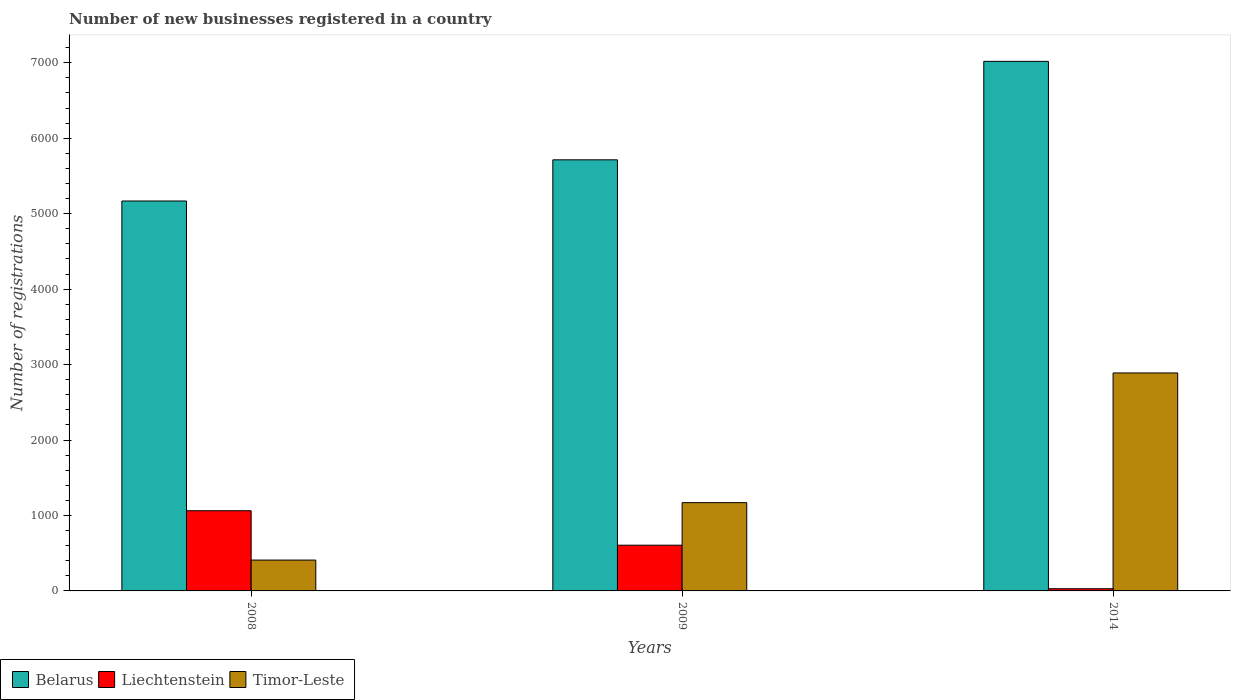How many different coloured bars are there?
Your response must be concise. 3. How many groups of bars are there?
Keep it short and to the point. 3. Are the number of bars per tick equal to the number of legend labels?
Make the answer very short. Yes. In how many cases, is the number of bars for a given year not equal to the number of legend labels?
Provide a short and direct response. 0. What is the number of new businesses registered in Belarus in 2009?
Make the answer very short. 5714. Across all years, what is the maximum number of new businesses registered in Belarus?
Ensure brevity in your answer.  7019. In which year was the number of new businesses registered in Timor-Leste maximum?
Provide a succinct answer. 2014. In which year was the number of new businesses registered in Timor-Leste minimum?
Provide a short and direct response. 2008. What is the total number of new businesses registered in Belarus in the graph?
Make the answer very short. 1.79e+04. What is the difference between the number of new businesses registered in Liechtenstein in 2009 and that in 2014?
Ensure brevity in your answer.  577. What is the difference between the number of new businesses registered in Liechtenstein in 2008 and the number of new businesses registered in Timor-Leste in 2009?
Your response must be concise. -107. What is the average number of new businesses registered in Belarus per year?
Your answer should be compact. 5967. In the year 2014, what is the difference between the number of new businesses registered in Timor-Leste and number of new businesses registered in Belarus?
Keep it short and to the point. -4130. What is the ratio of the number of new businesses registered in Liechtenstein in 2008 to that in 2009?
Your answer should be compact. 1.75. Is the number of new businesses registered in Belarus in 2008 less than that in 2009?
Provide a succinct answer. Yes. Is the difference between the number of new businesses registered in Timor-Leste in 2008 and 2014 greater than the difference between the number of new businesses registered in Belarus in 2008 and 2014?
Your answer should be very brief. No. What is the difference between the highest and the second highest number of new businesses registered in Liechtenstein?
Keep it short and to the point. 457. What is the difference between the highest and the lowest number of new businesses registered in Liechtenstein?
Give a very brief answer. 1034. Is the sum of the number of new businesses registered in Liechtenstein in 2009 and 2014 greater than the maximum number of new businesses registered in Timor-Leste across all years?
Provide a short and direct response. No. What does the 3rd bar from the left in 2008 represents?
Provide a short and direct response. Timor-Leste. What does the 2nd bar from the right in 2009 represents?
Make the answer very short. Liechtenstein. Is it the case that in every year, the sum of the number of new businesses registered in Liechtenstein and number of new businesses registered in Timor-Leste is greater than the number of new businesses registered in Belarus?
Your response must be concise. No. How many bars are there?
Keep it short and to the point. 9. Are all the bars in the graph horizontal?
Give a very brief answer. No. What is the difference between two consecutive major ticks on the Y-axis?
Make the answer very short. 1000. Are the values on the major ticks of Y-axis written in scientific E-notation?
Your answer should be very brief. No. Where does the legend appear in the graph?
Make the answer very short. Bottom left. How are the legend labels stacked?
Your response must be concise. Horizontal. What is the title of the graph?
Offer a very short reply. Number of new businesses registered in a country. Does "Marshall Islands" appear as one of the legend labels in the graph?
Give a very brief answer. No. What is the label or title of the X-axis?
Offer a terse response. Years. What is the label or title of the Y-axis?
Your answer should be very brief. Number of registrations. What is the Number of registrations of Belarus in 2008?
Make the answer very short. 5168. What is the Number of registrations of Liechtenstein in 2008?
Keep it short and to the point. 1063. What is the Number of registrations in Timor-Leste in 2008?
Offer a very short reply. 409. What is the Number of registrations in Belarus in 2009?
Your answer should be compact. 5714. What is the Number of registrations in Liechtenstein in 2009?
Your response must be concise. 606. What is the Number of registrations in Timor-Leste in 2009?
Provide a succinct answer. 1170. What is the Number of registrations of Belarus in 2014?
Keep it short and to the point. 7019. What is the Number of registrations in Timor-Leste in 2014?
Provide a short and direct response. 2889. Across all years, what is the maximum Number of registrations in Belarus?
Offer a terse response. 7019. Across all years, what is the maximum Number of registrations of Liechtenstein?
Offer a very short reply. 1063. Across all years, what is the maximum Number of registrations of Timor-Leste?
Provide a short and direct response. 2889. Across all years, what is the minimum Number of registrations in Belarus?
Offer a very short reply. 5168. Across all years, what is the minimum Number of registrations of Timor-Leste?
Your answer should be compact. 409. What is the total Number of registrations of Belarus in the graph?
Your answer should be compact. 1.79e+04. What is the total Number of registrations of Liechtenstein in the graph?
Make the answer very short. 1698. What is the total Number of registrations in Timor-Leste in the graph?
Your answer should be compact. 4468. What is the difference between the Number of registrations in Belarus in 2008 and that in 2009?
Offer a terse response. -546. What is the difference between the Number of registrations of Liechtenstein in 2008 and that in 2009?
Keep it short and to the point. 457. What is the difference between the Number of registrations of Timor-Leste in 2008 and that in 2009?
Give a very brief answer. -761. What is the difference between the Number of registrations of Belarus in 2008 and that in 2014?
Your answer should be very brief. -1851. What is the difference between the Number of registrations in Liechtenstein in 2008 and that in 2014?
Keep it short and to the point. 1034. What is the difference between the Number of registrations in Timor-Leste in 2008 and that in 2014?
Ensure brevity in your answer.  -2480. What is the difference between the Number of registrations of Belarus in 2009 and that in 2014?
Offer a terse response. -1305. What is the difference between the Number of registrations in Liechtenstein in 2009 and that in 2014?
Provide a succinct answer. 577. What is the difference between the Number of registrations in Timor-Leste in 2009 and that in 2014?
Give a very brief answer. -1719. What is the difference between the Number of registrations of Belarus in 2008 and the Number of registrations of Liechtenstein in 2009?
Make the answer very short. 4562. What is the difference between the Number of registrations in Belarus in 2008 and the Number of registrations in Timor-Leste in 2009?
Keep it short and to the point. 3998. What is the difference between the Number of registrations in Liechtenstein in 2008 and the Number of registrations in Timor-Leste in 2009?
Your response must be concise. -107. What is the difference between the Number of registrations of Belarus in 2008 and the Number of registrations of Liechtenstein in 2014?
Give a very brief answer. 5139. What is the difference between the Number of registrations in Belarus in 2008 and the Number of registrations in Timor-Leste in 2014?
Your answer should be compact. 2279. What is the difference between the Number of registrations of Liechtenstein in 2008 and the Number of registrations of Timor-Leste in 2014?
Keep it short and to the point. -1826. What is the difference between the Number of registrations in Belarus in 2009 and the Number of registrations in Liechtenstein in 2014?
Provide a succinct answer. 5685. What is the difference between the Number of registrations in Belarus in 2009 and the Number of registrations in Timor-Leste in 2014?
Provide a short and direct response. 2825. What is the difference between the Number of registrations of Liechtenstein in 2009 and the Number of registrations of Timor-Leste in 2014?
Provide a succinct answer. -2283. What is the average Number of registrations of Belarus per year?
Your answer should be very brief. 5967. What is the average Number of registrations of Liechtenstein per year?
Provide a succinct answer. 566. What is the average Number of registrations in Timor-Leste per year?
Provide a short and direct response. 1489.33. In the year 2008, what is the difference between the Number of registrations in Belarus and Number of registrations in Liechtenstein?
Offer a terse response. 4105. In the year 2008, what is the difference between the Number of registrations in Belarus and Number of registrations in Timor-Leste?
Make the answer very short. 4759. In the year 2008, what is the difference between the Number of registrations in Liechtenstein and Number of registrations in Timor-Leste?
Provide a short and direct response. 654. In the year 2009, what is the difference between the Number of registrations in Belarus and Number of registrations in Liechtenstein?
Provide a short and direct response. 5108. In the year 2009, what is the difference between the Number of registrations of Belarus and Number of registrations of Timor-Leste?
Keep it short and to the point. 4544. In the year 2009, what is the difference between the Number of registrations of Liechtenstein and Number of registrations of Timor-Leste?
Your answer should be compact. -564. In the year 2014, what is the difference between the Number of registrations in Belarus and Number of registrations in Liechtenstein?
Provide a short and direct response. 6990. In the year 2014, what is the difference between the Number of registrations in Belarus and Number of registrations in Timor-Leste?
Ensure brevity in your answer.  4130. In the year 2014, what is the difference between the Number of registrations in Liechtenstein and Number of registrations in Timor-Leste?
Your answer should be compact. -2860. What is the ratio of the Number of registrations in Belarus in 2008 to that in 2009?
Provide a short and direct response. 0.9. What is the ratio of the Number of registrations of Liechtenstein in 2008 to that in 2009?
Your answer should be compact. 1.75. What is the ratio of the Number of registrations in Timor-Leste in 2008 to that in 2009?
Keep it short and to the point. 0.35. What is the ratio of the Number of registrations of Belarus in 2008 to that in 2014?
Give a very brief answer. 0.74. What is the ratio of the Number of registrations in Liechtenstein in 2008 to that in 2014?
Offer a very short reply. 36.66. What is the ratio of the Number of registrations of Timor-Leste in 2008 to that in 2014?
Give a very brief answer. 0.14. What is the ratio of the Number of registrations in Belarus in 2009 to that in 2014?
Keep it short and to the point. 0.81. What is the ratio of the Number of registrations in Liechtenstein in 2009 to that in 2014?
Keep it short and to the point. 20.9. What is the ratio of the Number of registrations in Timor-Leste in 2009 to that in 2014?
Make the answer very short. 0.41. What is the difference between the highest and the second highest Number of registrations of Belarus?
Your answer should be compact. 1305. What is the difference between the highest and the second highest Number of registrations in Liechtenstein?
Ensure brevity in your answer.  457. What is the difference between the highest and the second highest Number of registrations of Timor-Leste?
Give a very brief answer. 1719. What is the difference between the highest and the lowest Number of registrations in Belarus?
Offer a very short reply. 1851. What is the difference between the highest and the lowest Number of registrations in Liechtenstein?
Provide a short and direct response. 1034. What is the difference between the highest and the lowest Number of registrations of Timor-Leste?
Provide a short and direct response. 2480. 